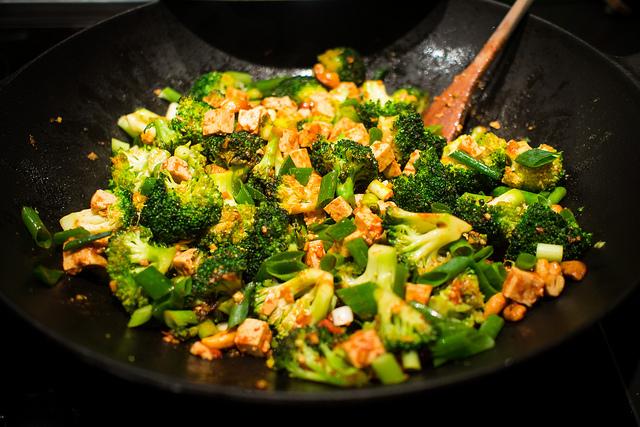What is the spoon made of?
Quick response, please. Wood. Is there a fork or spoon on the plate?
Be succinct. Spoon. What is cooking on the pan?
Be succinct. Broccoli. What is the green vegetable?
Give a very brief answer. Broccoli. 